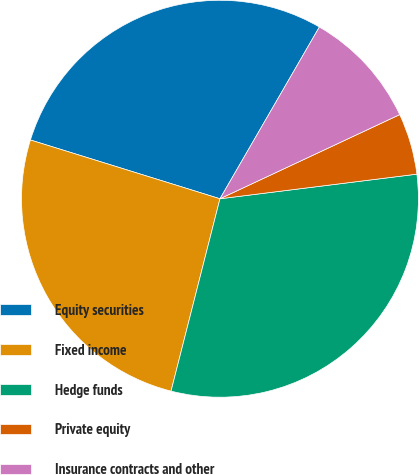<chart> <loc_0><loc_0><loc_500><loc_500><pie_chart><fcel>Equity securities<fcel>Fixed income<fcel>Hedge funds<fcel>Private equity<fcel>Insurance contracts and other<nl><fcel>28.56%<fcel>25.82%<fcel>30.94%<fcel>4.99%<fcel>9.68%<nl></chart> 